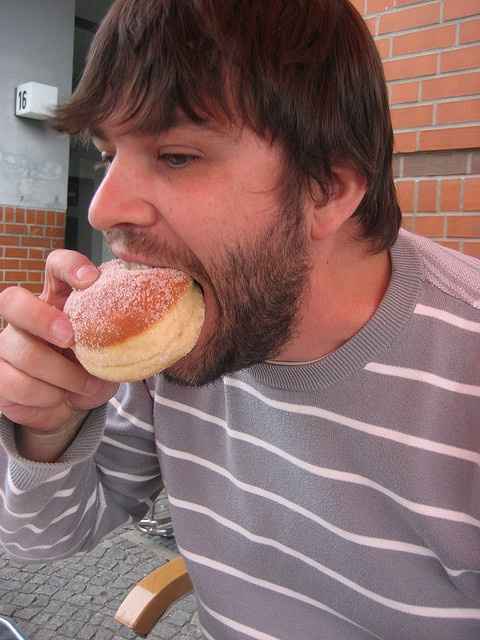Describe the objects in this image and their specific colors. I can see people in gray, brown, and black tones, donut in gray, tan, salmon, and brown tones, and chair in gray, maroon, tan, and lightgray tones in this image. 